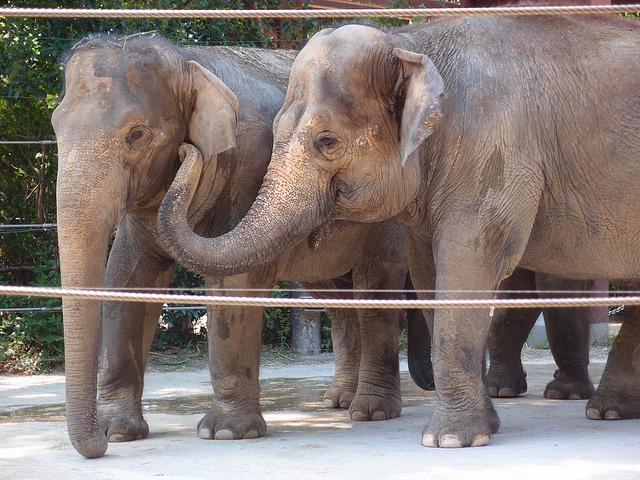How many elephants are there?
Keep it brief. 2. Was this taken inside?
Be succinct. No. Do the elephants look happy?
Answer briefly. Yes. 